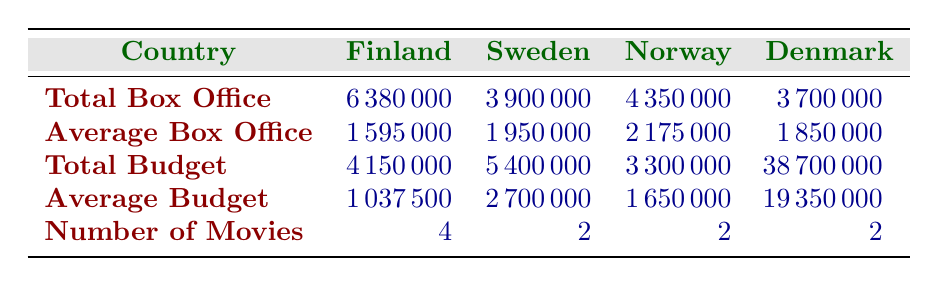What is the total box office for horror movies in Finland? The table shows that the total box office for horror movies in Finland is 6,380,000. This value is explicitly listed under the 'Total Box Office' row for Finland.
Answer: 6,380,000 Which country has the highest average box office for horror movies? To find the country with the highest average box office, we compare the average box office values from each country: Finland (1,595,000), Sweden (1,950,000), Norway (2,175,000), and Denmark (1,850,000). Norway has the highest average box office value.
Answer: Norway What is the total budget for horror movies in Denmark? The total budget for horror movies in Denmark is provided directly in the table, showing a value of 38,700,000.
Answer: 38,700,000 How many movies were released in Norway? The table indicates that Norway has 2 horror movies listed, which is found under the 'Number of Movies' row for Norway.
Answer: 2 What is the difference between the total box office in Finland and Sweden? The total box office for Finland is 6,380,000 and for Sweden is 3,900,000. To find the difference, we subtract the total box office in Sweden from that in Finland: 6,380,000 - 3,900,000 = 2,480,000.
Answer: 2,480,000 Is the average budget for movies in Norway higher than in Sweden? The average budget for Norway is 1,650,000 while for Sweden it is 2,700,000. Since 1,650,000 is less than 2,700,000, the statement is false.
Answer: No What is the total box office of horror movies in the Nordic countries? The total box office for all Nordic countries can be calculated by summing up all the individual total box office values: Finland (6,380,000) + Sweden (3,900,000) + Norway (4,350,000) + Denmark (3,700,000) = 18,330,000.
Answer: 18,330,000 Which country has the lowest total box office for horror movies? The table presents the total box office for each country: Finland (6,380,000), Sweden (3,900,000), Norway (4,350,000), and Denmark (3,700,000). The country with the lowest total box office is Denmark with 3,700,000.
Answer: Denmark What is the average budget for Finnish horror movies? The average budget for Finnish horror movies is listed directly in the table as 1,037,500. This value is under the 'Average Budget' row for Finland.
Answer: 1,037,500 